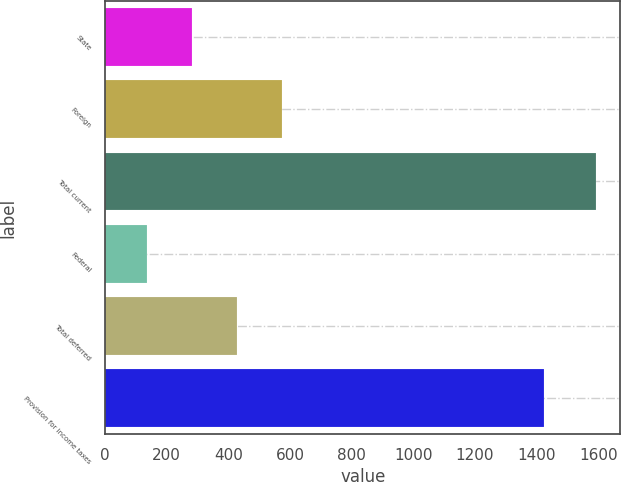Convert chart to OTSL. <chart><loc_0><loc_0><loc_500><loc_500><bar_chart><fcel>State<fcel>Foreign<fcel>Total current<fcel>Federal<fcel>Total deferred<fcel>Provision for income taxes<nl><fcel>280.7<fcel>572.1<fcel>1592<fcel>135<fcel>426.4<fcel>1424<nl></chart> 